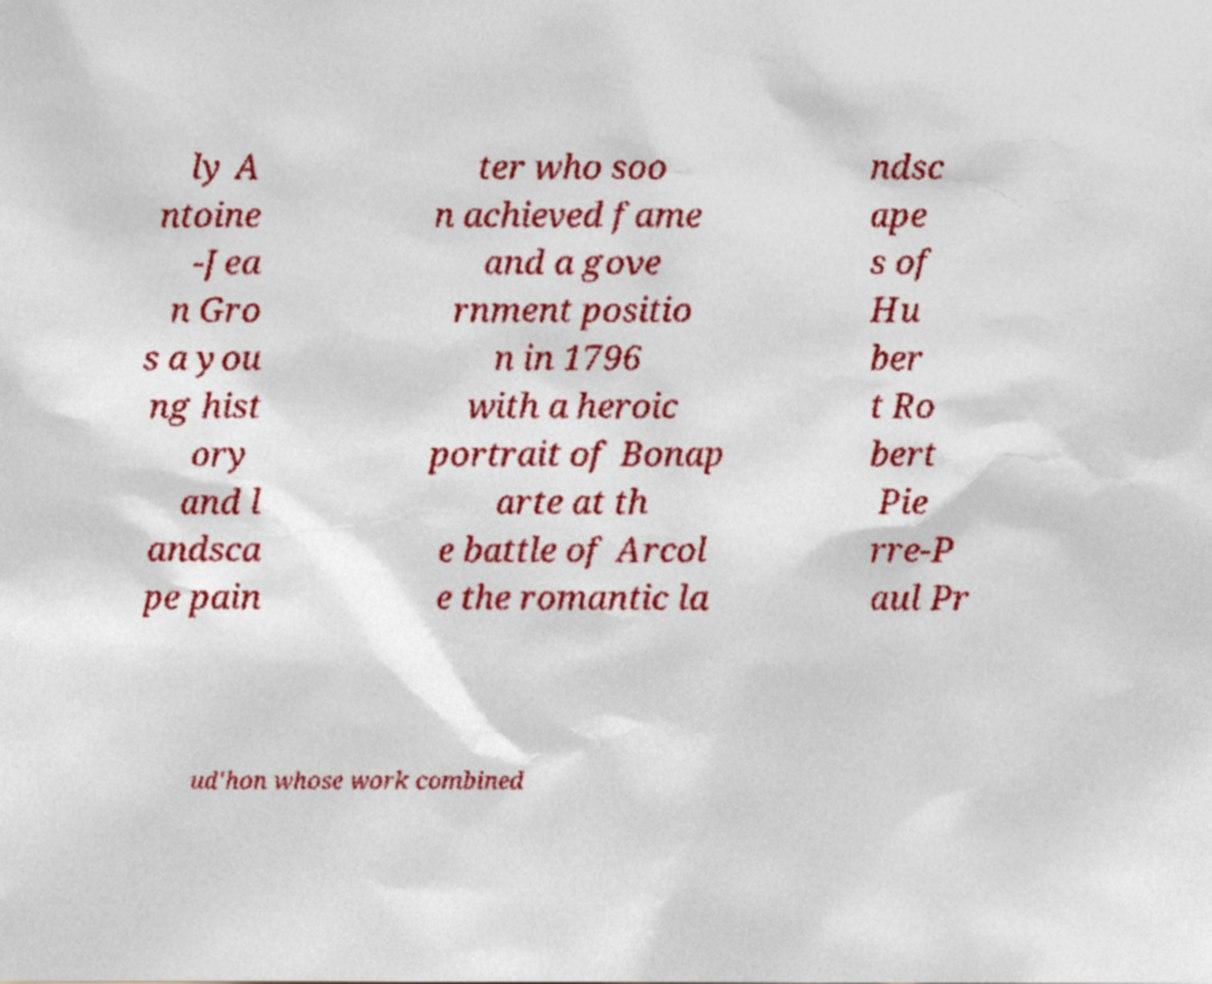What messages or text are displayed in this image? I need them in a readable, typed format. ly A ntoine -Jea n Gro s a you ng hist ory and l andsca pe pain ter who soo n achieved fame and a gove rnment positio n in 1796 with a heroic portrait of Bonap arte at th e battle of Arcol e the romantic la ndsc ape s of Hu ber t Ro bert Pie rre-P aul Pr ud'hon whose work combined 